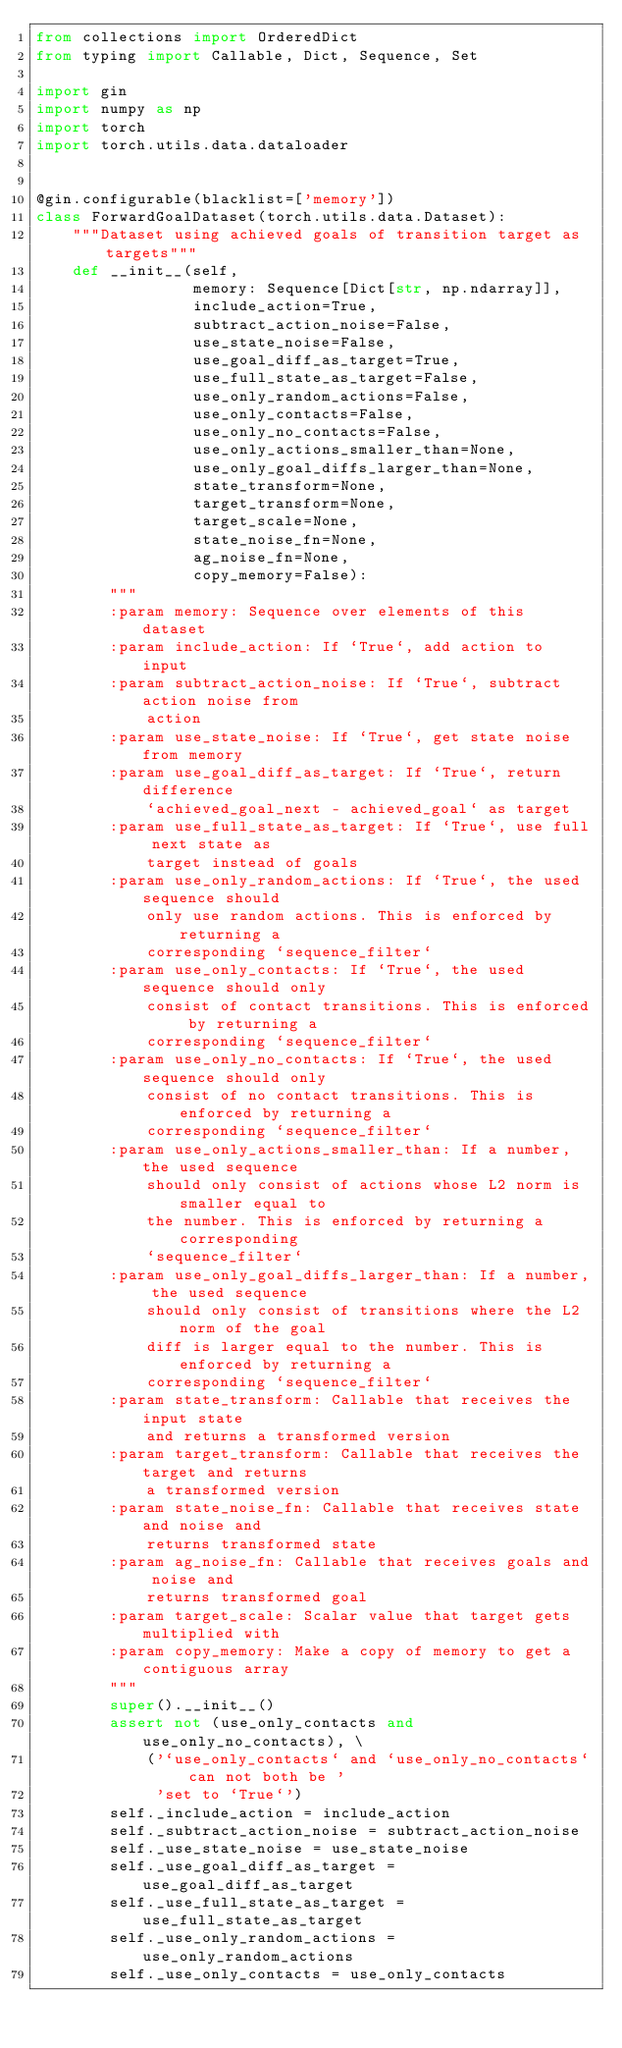<code> <loc_0><loc_0><loc_500><loc_500><_Python_>from collections import OrderedDict
from typing import Callable, Dict, Sequence, Set

import gin
import numpy as np
import torch
import torch.utils.data.dataloader


@gin.configurable(blacklist=['memory'])
class ForwardGoalDataset(torch.utils.data.Dataset):
    """Dataset using achieved goals of transition target as targets"""
    def __init__(self,
                 memory: Sequence[Dict[str, np.ndarray]],
                 include_action=True,
                 subtract_action_noise=False,
                 use_state_noise=False,
                 use_goal_diff_as_target=True,
                 use_full_state_as_target=False,
                 use_only_random_actions=False,
                 use_only_contacts=False,
                 use_only_no_contacts=False,
                 use_only_actions_smaller_than=None,
                 use_only_goal_diffs_larger_than=None,
                 state_transform=None,
                 target_transform=None,
                 target_scale=None,
                 state_noise_fn=None,
                 ag_noise_fn=None,
                 copy_memory=False):
        """
        :param memory: Sequence over elements of this dataset
        :param include_action: If `True`, add action to input
        :param subtract_action_noise: If `True`, subtract action noise from
            action
        :param use_state_noise: If `True`, get state noise from memory
        :param use_goal_diff_as_target: If `True`, return difference
            `achieved_goal_next - achieved_goal` as target
        :param use_full_state_as_target: If `True`, use full next state as
            target instead of goals
        :param use_only_random_actions: If `True`, the used sequence should
            only use random actions. This is enforced by returning a
            corresponding `sequence_filter`
        :param use_only_contacts: If `True`, the used sequence should only
            consist of contact transitions. This is enforced by returning a
            corresponding `sequence_filter`
        :param use_only_no_contacts: If `True`, the used sequence should only
            consist of no contact transitions. This is enforced by returning a
            corresponding `sequence_filter`
        :param use_only_actions_smaller_than: If a number, the used sequence
            should only consist of actions whose L2 norm is smaller equal to
            the number. This is enforced by returning a corresponding
            `sequence_filter`
        :param use_only_goal_diffs_larger_than: If a number, the used sequence
            should only consist of transitions where the L2 norm of the goal
            diff is larger equal to the number. This is enforced by returning a
            corresponding `sequence_filter`
        :param state_transform: Callable that receives the input state
            and returns a transformed version
        :param target_transform: Callable that receives the target and returns
            a transformed version
        :param state_noise_fn: Callable that receives state and noise and
            returns transformed state
        :param ag_noise_fn: Callable that receives goals and noise and
            returns transformed goal
        :param target_scale: Scalar value that target gets multiplied with
        :param copy_memory: Make a copy of memory to get a contiguous array
        """
        super().__init__()
        assert not (use_only_contacts and use_only_no_contacts), \
            ('`use_only_contacts` and `use_only_no_contacts` can not both be '
             'set to `True`')
        self._include_action = include_action
        self._subtract_action_noise = subtract_action_noise
        self._use_state_noise = use_state_noise
        self._use_goal_diff_as_target = use_goal_diff_as_target
        self._use_full_state_as_target = use_full_state_as_target
        self._use_only_random_actions = use_only_random_actions
        self._use_only_contacts = use_only_contacts</code> 